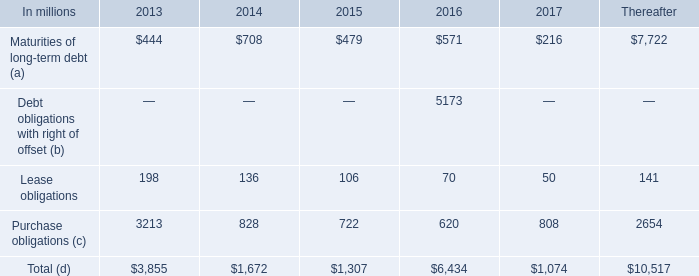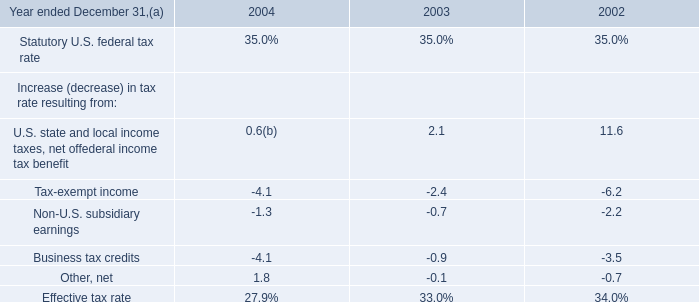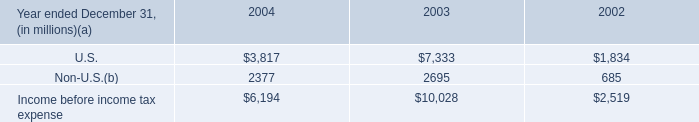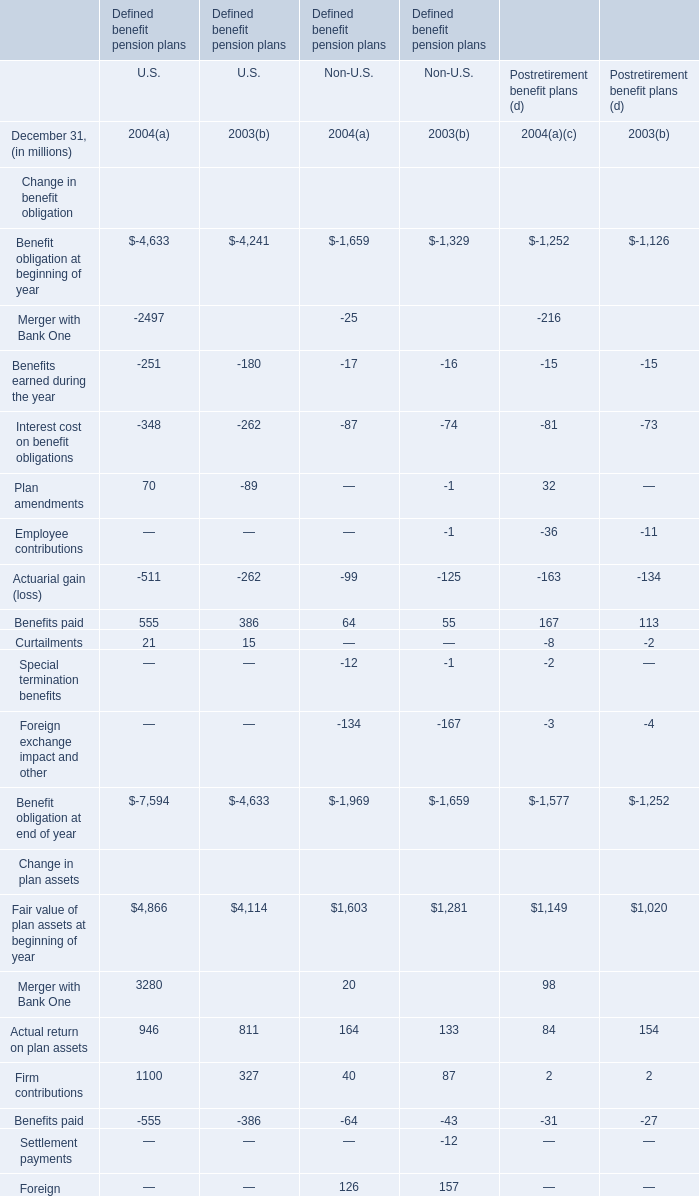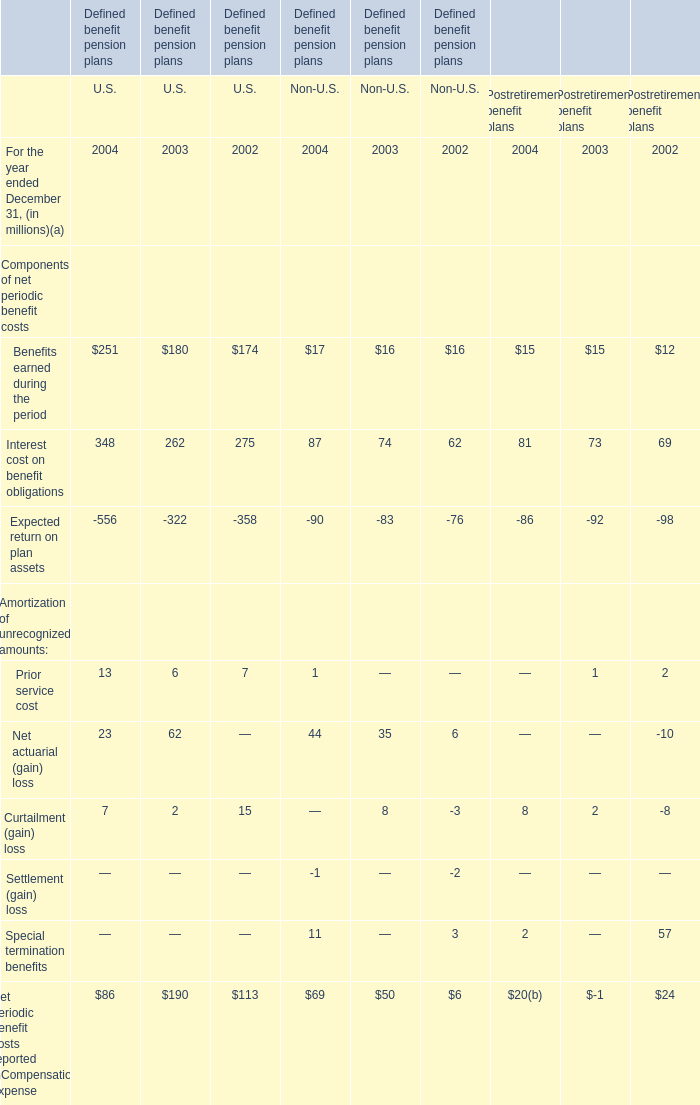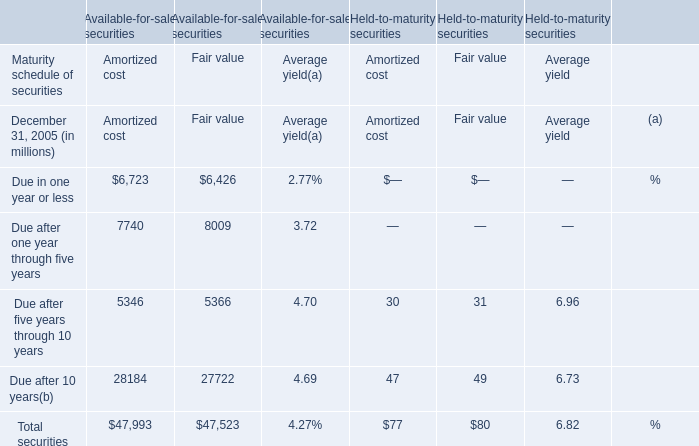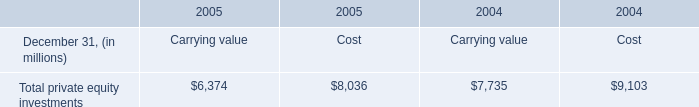What's the growth rate of Actual return on plan assets for U.S. in 2004? 
Computations: ((946 - 811) / 811)
Answer: 0.16646. 